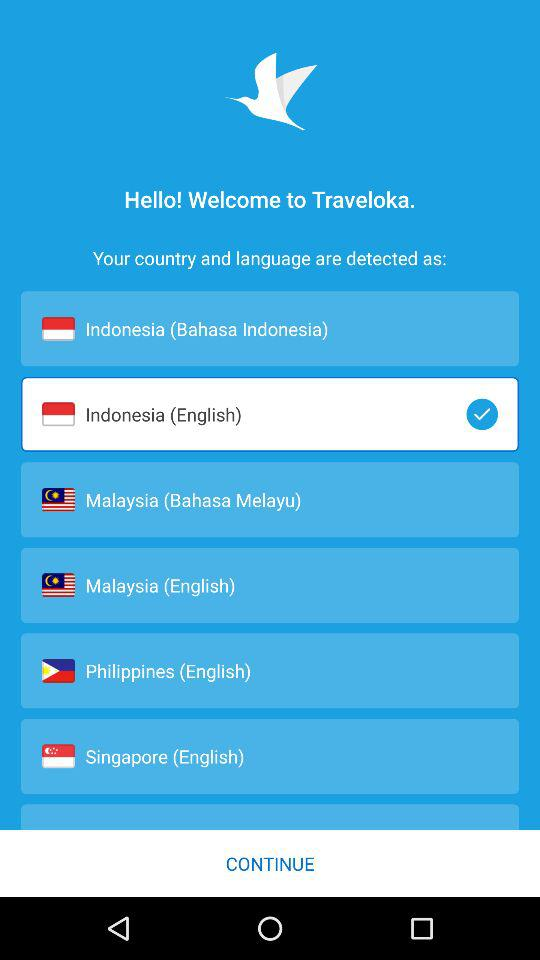Which language is selected? The selected language is Indonesia (English). 